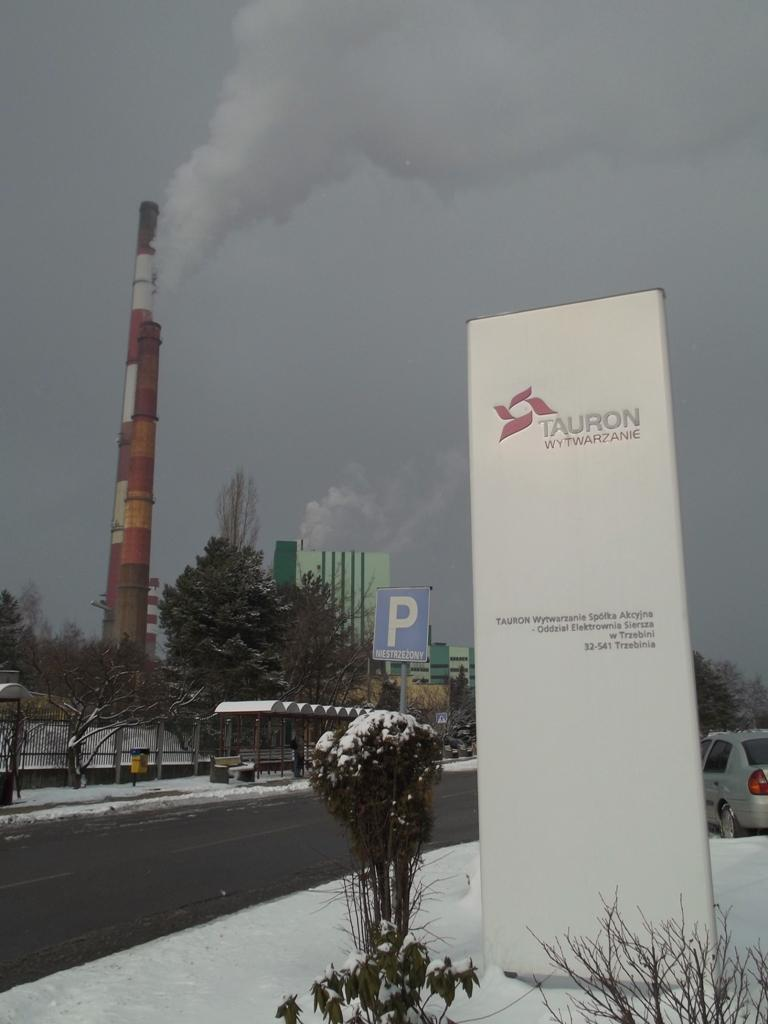What is the main feature of the image? There is a road in the image. What can be seen near the road? There are trees near the road. What is covering the boards in the image? The boards are covered with snow in the image. What type of clam can be seen crawling on the road in the image? There are no clams present in the image; it features a road, trees, and boards covered with snow. 